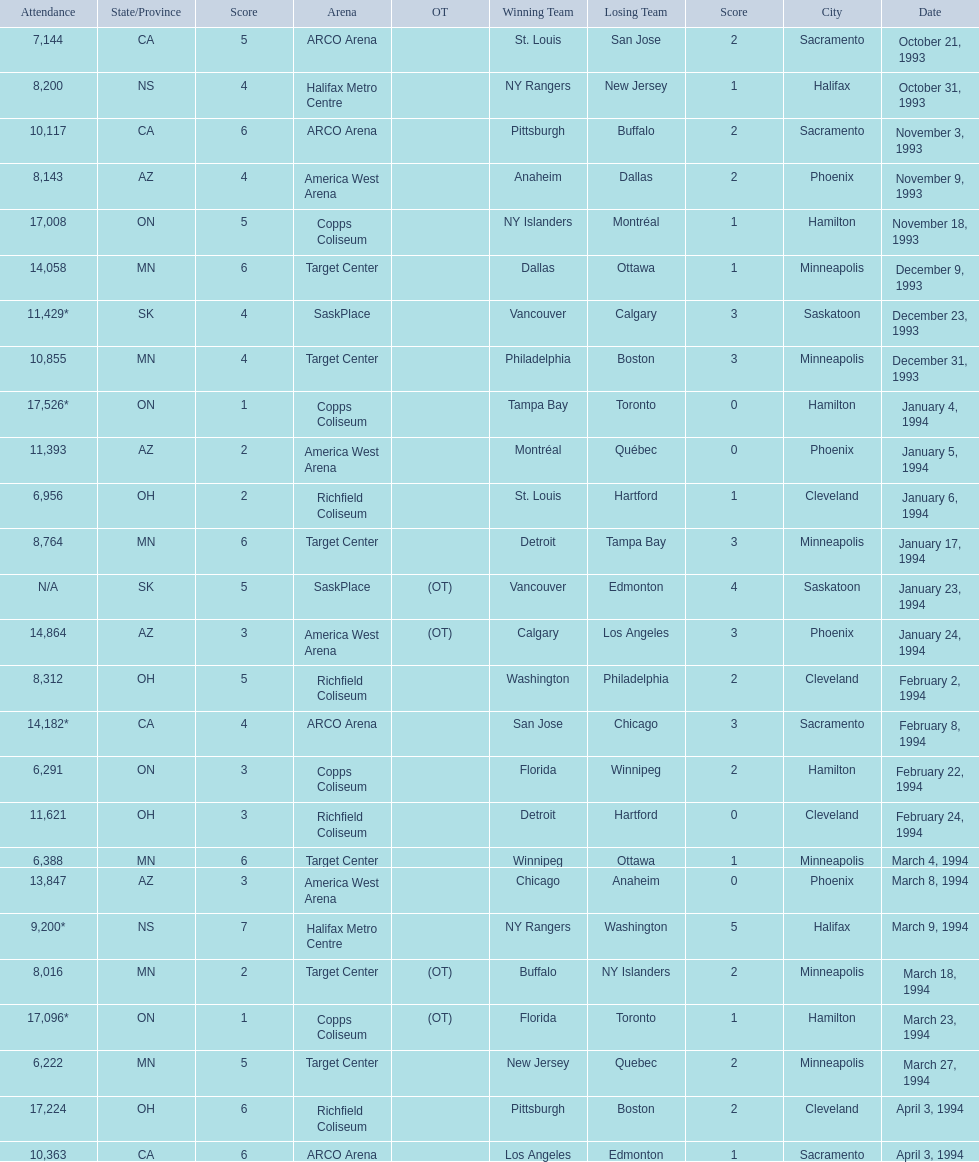On which dates were all the games? October 21, 1993, October 31, 1993, November 3, 1993, November 9, 1993, November 18, 1993, December 9, 1993, December 23, 1993, December 31, 1993, January 4, 1994, January 5, 1994, January 6, 1994, January 17, 1994, January 23, 1994, January 24, 1994, February 2, 1994, February 8, 1994, February 22, 1994, February 24, 1994, March 4, 1994, March 8, 1994, March 9, 1994, March 18, 1994, March 23, 1994, March 27, 1994, April 3, 1994, April 3, 1994. What were the attendances? 7,144, 8,200, 10,117, 8,143, 17,008, 14,058, 11,429*, 10,855, 17,526*, 11,393, 6,956, 8,764, N/A, 14,864, 8,312, 14,182*, 6,291, 11,621, 6,388, 13,847, 9,200*, 8,016, 17,096*, 6,222, 17,224, 10,363. And between december 23, 1993 and january 24, 1994, which game had the highest turnout? January 4, 1994. 